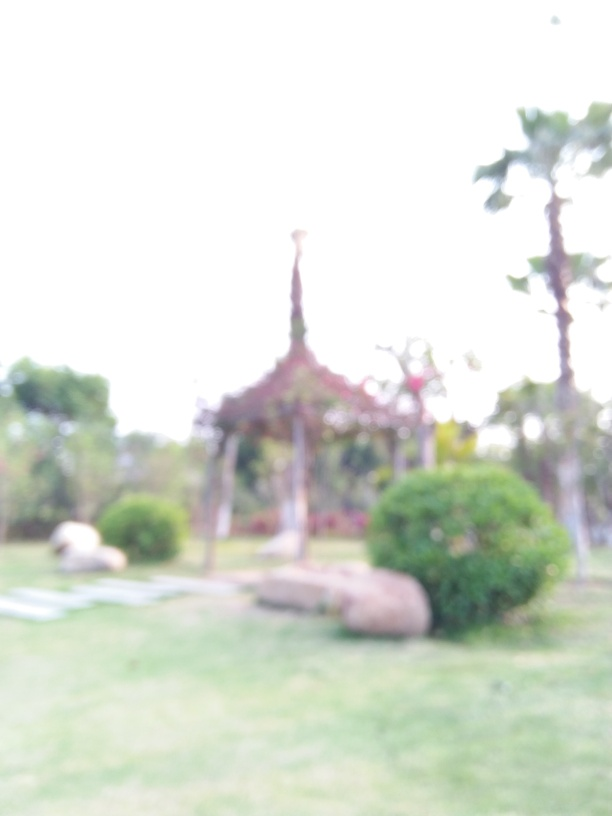Despite the blur, can you guess what time of day it might be? Judging by the overall brightness and the diffused lighting in the image, it suggests that the photo could have been taken during daylight hours, possibly late afternoon based on the softness of the light. The absence of harsh shadows or strong light contrasts usually associated with midday sun further supports this hypothesis. 